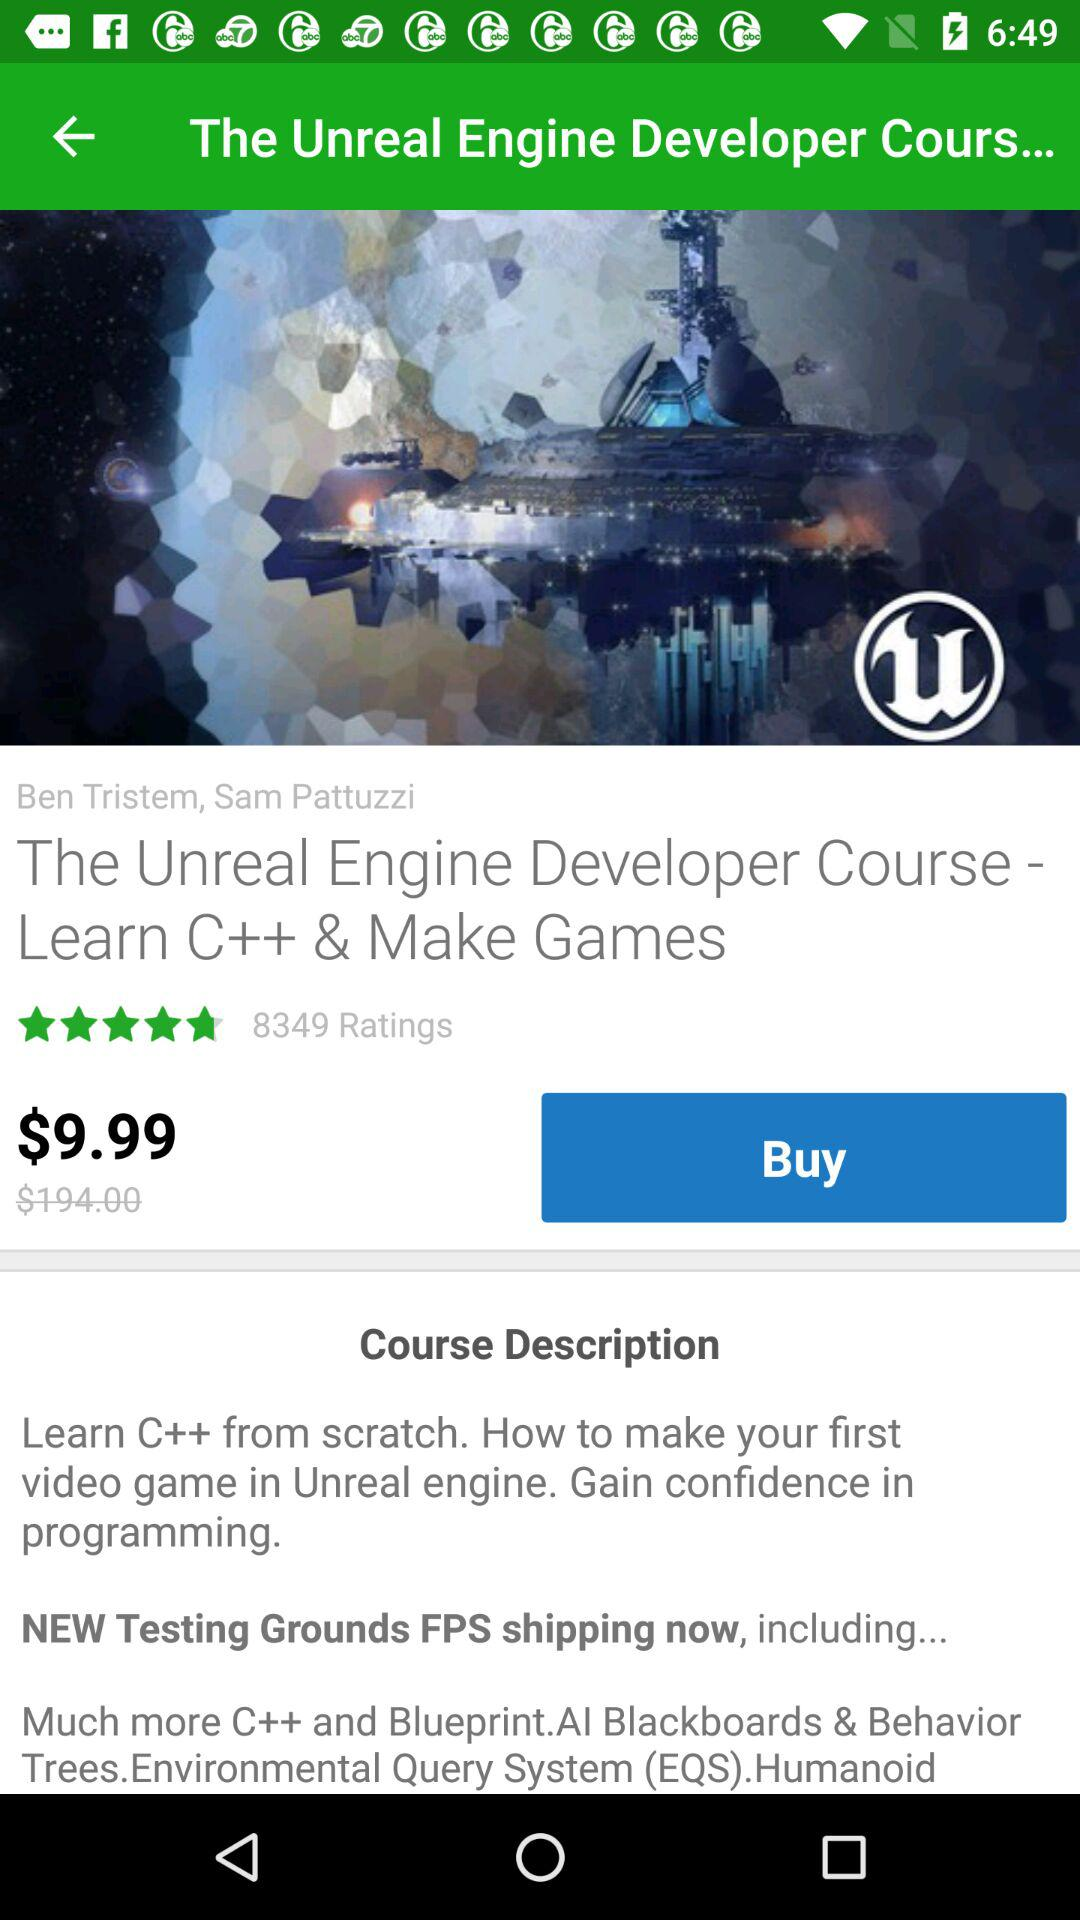What's the discounted price of the course? The discounted price is $9.99. 